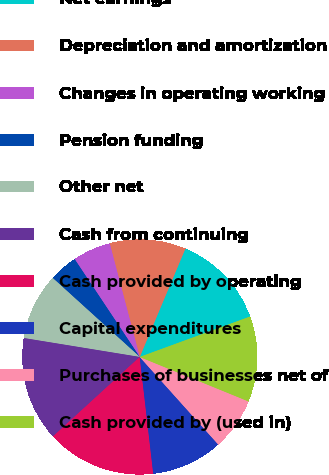Convert chart. <chart><loc_0><loc_0><loc_500><loc_500><pie_chart><fcel>Net earnings<fcel>Depreciation and amortization<fcel>Changes in operating working<fcel>Pension funding<fcel>Other net<fcel>Cash from continuing<fcel>Cash provided by operating<fcel>Capital expenditures<fcel>Purchases of businesses net of<fcel>Cash provided by (used in)<nl><fcel>13.07%<fcel>10.46%<fcel>5.23%<fcel>3.93%<fcel>9.15%<fcel>14.38%<fcel>15.03%<fcel>9.8%<fcel>7.19%<fcel>11.76%<nl></chart> 